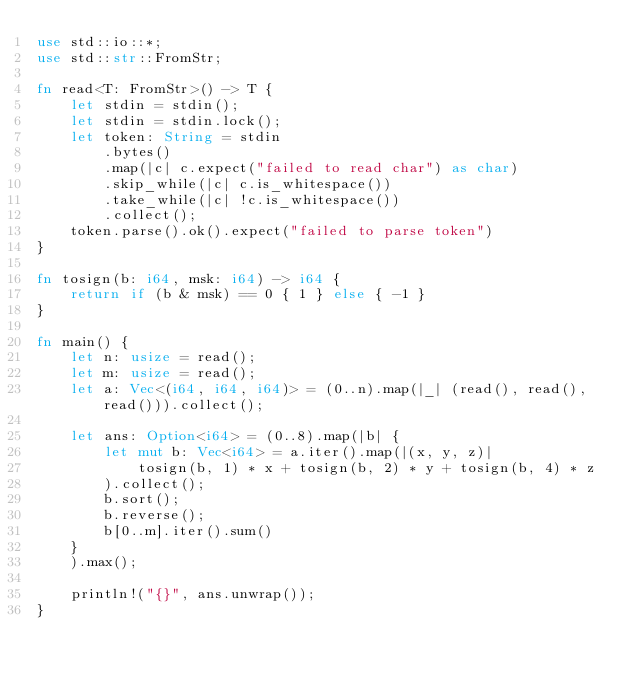<code> <loc_0><loc_0><loc_500><loc_500><_Rust_>use std::io::*;
use std::str::FromStr;

fn read<T: FromStr>() -> T {
    let stdin = stdin();
    let stdin = stdin.lock();
    let token: String = stdin
        .bytes()
        .map(|c| c.expect("failed to read char") as char)
        .skip_while(|c| c.is_whitespace())
        .take_while(|c| !c.is_whitespace())
        .collect();
    token.parse().ok().expect("failed to parse token")
}

fn tosign(b: i64, msk: i64) -> i64 {
    return if (b & msk) == 0 { 1 } else { -1 }
}

fn main() {
    let n: usize = read();
    let m: usize = read();
    let a: Vec<(i64, i64, i64)> = (0..n).map(|_| (read(), read(), read())).collect();

    let ans: Option<i64> = (0..8).map(|b| {
        let mut b: Vec<i64> = a.iter().map(|(x, y, z)|
            tosign(b, 1) * x + tosign(b, 2) * y + tosign(b, 4) * z
        ).collect();
        b.sort();
        b.reverse();
        b[0..m].iter().sum()
    }
    ).max();

    println!("{}", ans.unwrap());
}
</code> 